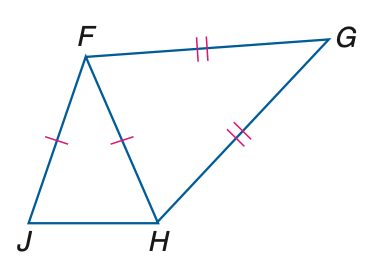Question: In the figure, F J \cong F H and G F \cong G H. If m \angle G H J = 152 and m \angle G = 32, find m \angle J F H.
Choices:
A. 12
B. 24
C. 32
D. 78
Answer with the letter. Answer: B Question: In the figure, F J \cong F H and G F \cong G H. If m \angle J F H = 34, find m \angle J.
Choices:
A. 34
B. 73
C. 112
D. 146
Answer with the letter. Answer: B 